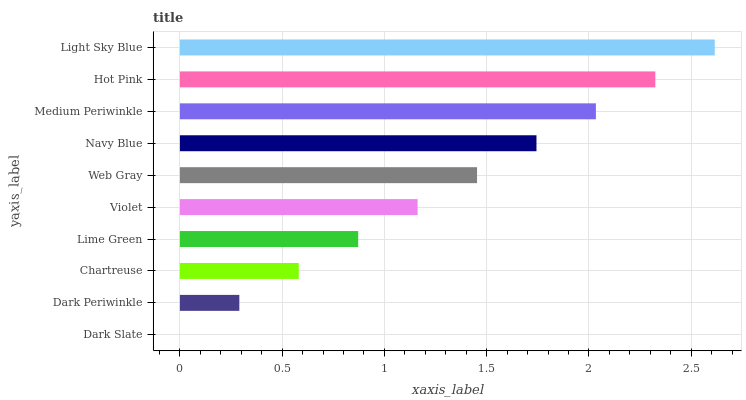Is Dark Slate the minimum?
Answer yes or no. Yes. Is Light Sky Blue the maximum?
Answer yes or no. Yes. Is Dark Periwinkle the minimum?
Answer yes or no. No. Is Dark Periwinkle the maximum?
Answer yes or no. No. Is Dark Periwinkle greater than Dark Slate?
Answer yes or no. Yes. Is Dark Slate less than Dark Periwinkle?
Answer yes or no. Yes. Is Dark Slate greater than Dark Periwinkle?
Answer yes or no. No. Is Dark Periwinkle less than Dark Slate?
Answer yes or no. No. Is Web Gray the high median?
Answer yes or no. Yes. Is Violet the low median?
Answer yes or no. Yes. Is Medium Periwinkle the high median?
Answer yes or no. No. Is Dark Slate the low median?
Answer yes or no. No. 